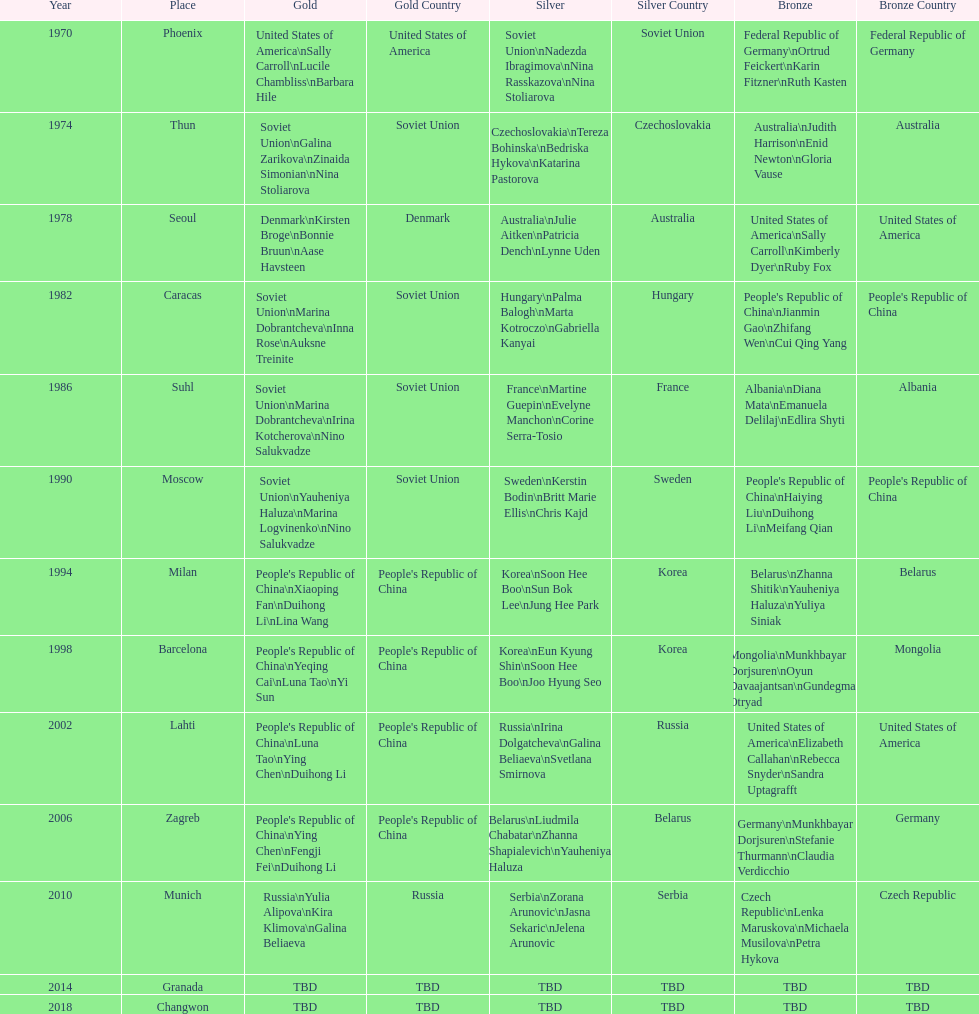Whose name is listed before bonnie bruun's in the gold column? Kirsten Broge. 